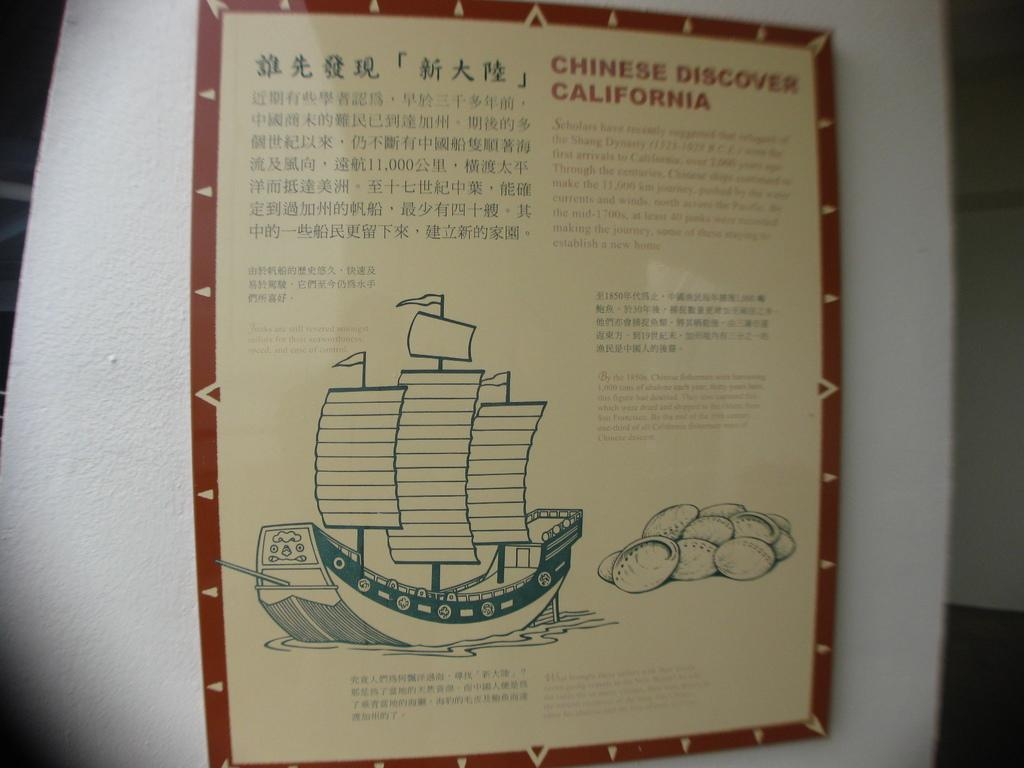Provide a one-sentence caption for the provided image. A museum board with the title 'Chinese Discover California.'. 